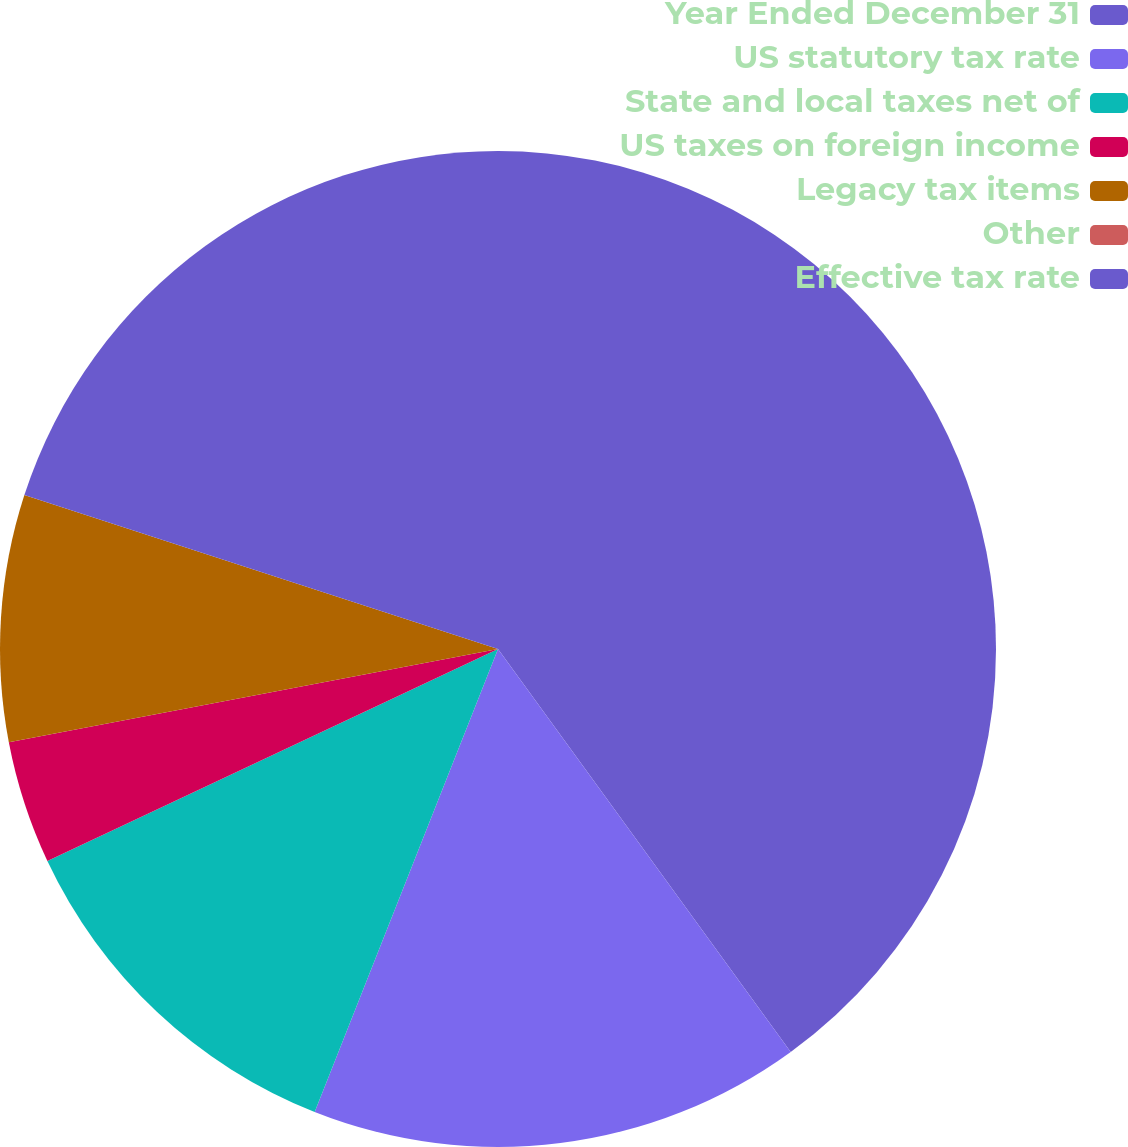Convert chart. <chart><loc_0><loc_0><loc_500><loc_500><pie_chart><fcel>Year Ended December 31<fcel>US statutory tax rate<fcel>State and local taxes net of<fcel>US taxes on foreign income<fcel>Legacy tax items<fcel>Other<fcel>Effective tax rate<nl><fcel>40.0%<fcel>16.0%<fcel>12.0%<fcel>4.0%<fcel>8.0%<fcel>0.0%<fcel>20.0%<nl></chart> 